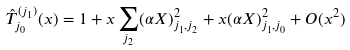<formula> <loc_0><loc_0><loc_500><loc_500>\hat { T } _ { j _ { 0 } } ^ { ( j _ { 1 } ) } ( x ) = 1 + x \sum _ { j _ { 2 } } ( \alpha X ) _ { j _ { 1 } , j _ { 2 } } ^ { 2 } + x ( \alpha X ) _ { j _ { 1 } , j _ { 0 } } ^ { 2 } + O ( x ^ { 2 } )</formula> 